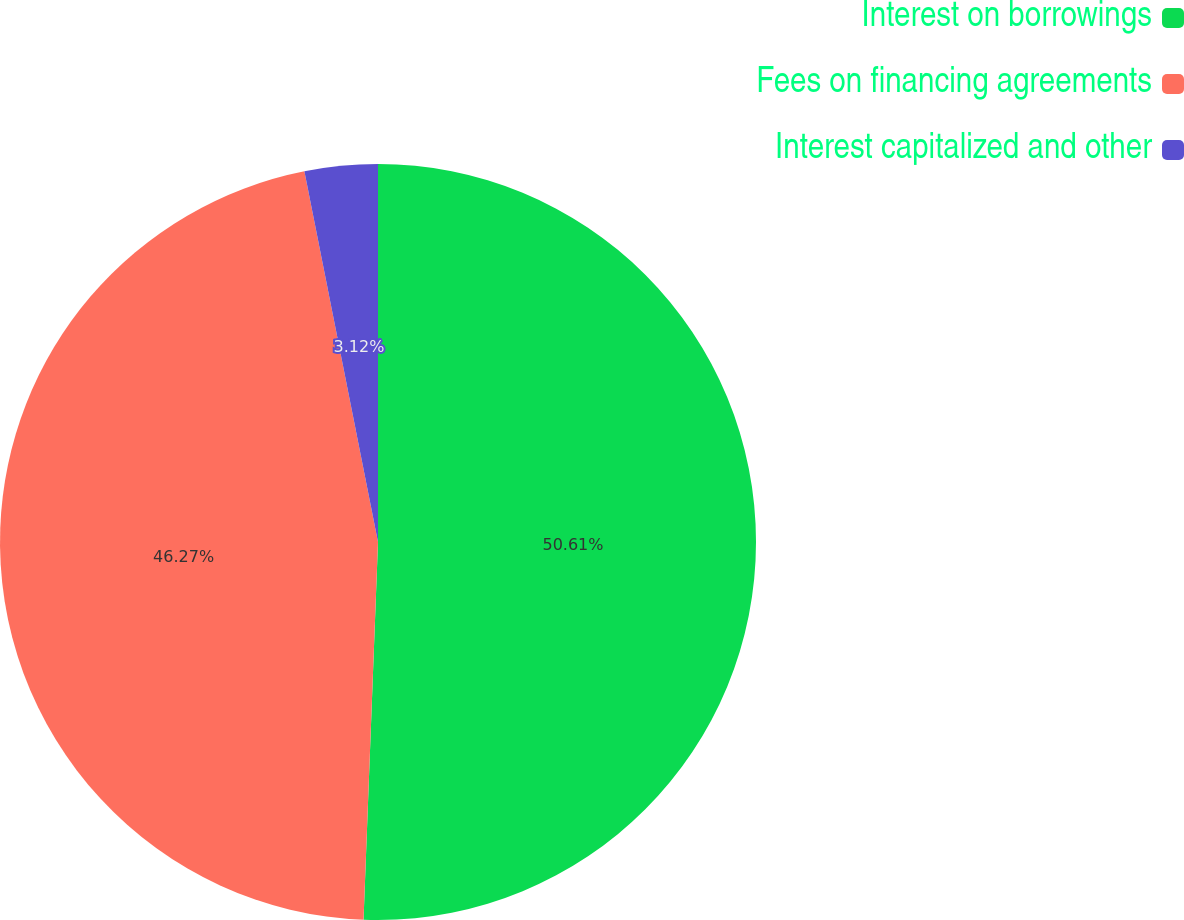Convert chart. <chart><loc_0><loc_0><loc_500><loc_500><pie_chart><fcel>Interest on borrowings<fcel>Fees on financing agreements<fcel>Interest capitalized and other<nl><fcel>50.61%<fcel>46.27%<fcel>3.12%<nl></chart> 